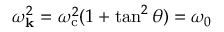<formula> <loc_0><loc_0><loc_500><loc_500>\omega _ { k } ^ { 2 } = \omega _ { c } ^ { 2 } ( 1 + \tan ^ { 2 } \theta ) = \omega _ { 0 }</formula> 